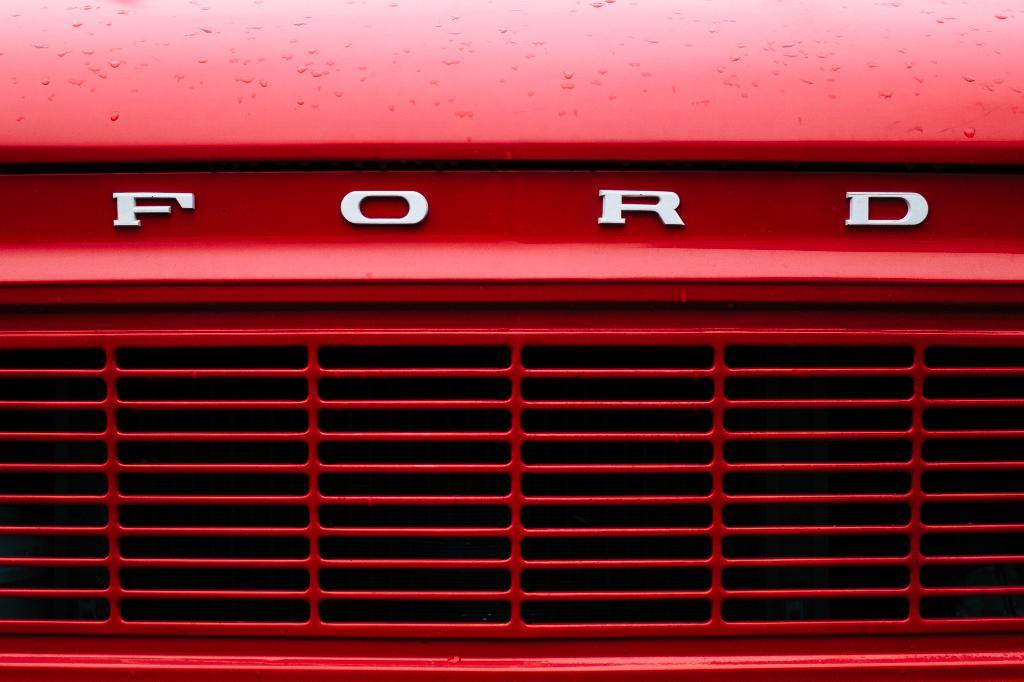What is the main subject of the image? There is a car in the image. What color is the car? The car is red. Which part of the car can be seen in the image? The front part of the car is visible in the image. What type of baseball is the car playing in the image? There is no baseball or any indication of a game in the image; it features a red car with the front part visible. 